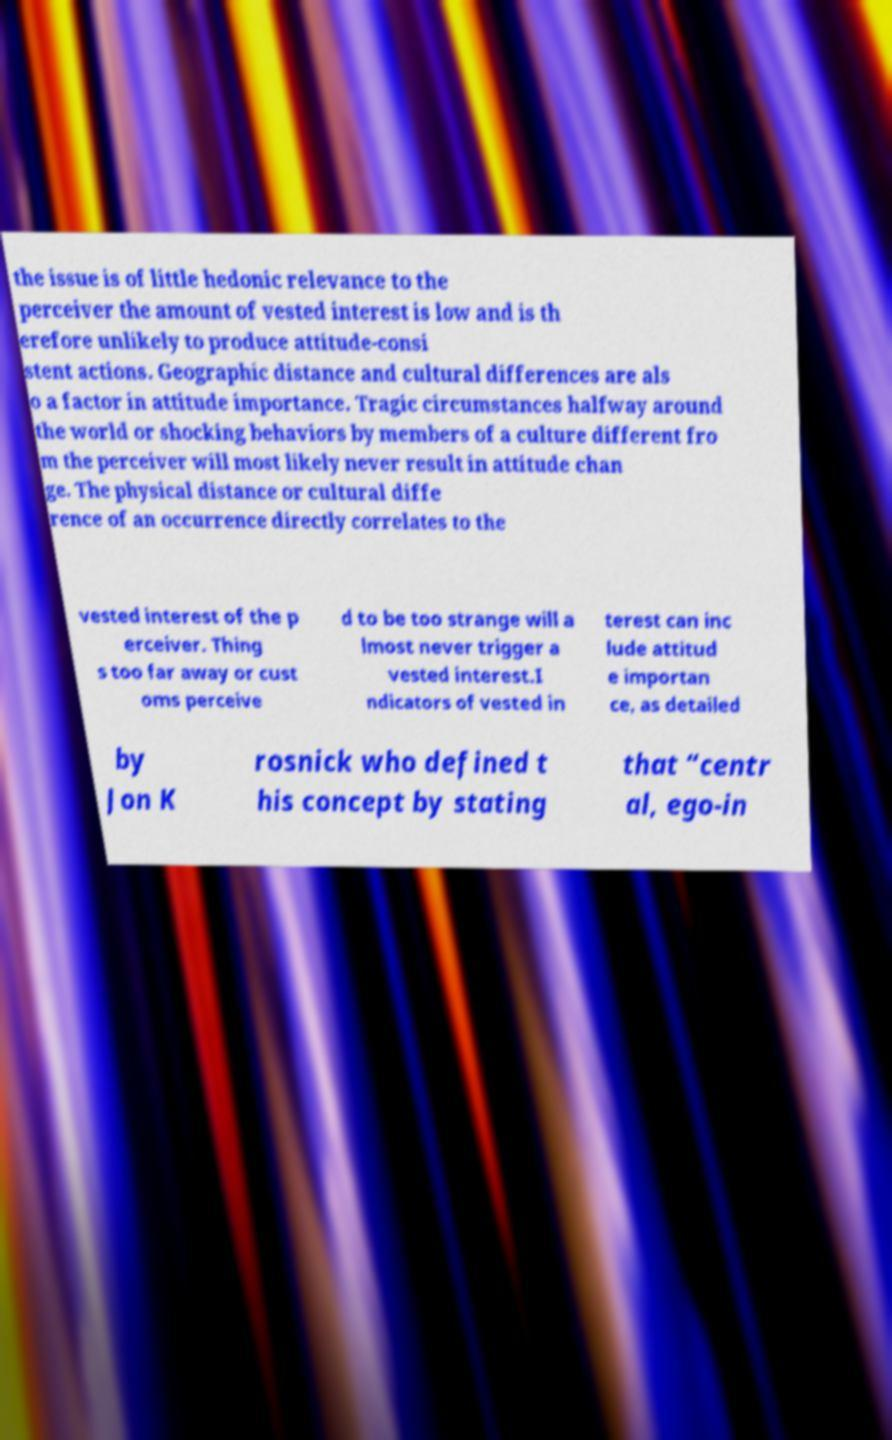What messages or text are displayed in this image? I need them in a readable, typed format. the issue is of little hedonic relevance to the perceiver the amount of vested interest is low and is th erefore unlikely to produce attitude-consi stent actions. Geographic distance and cultural differences are als o a factor in attitude importance. Tragic circumstances halfway around the world or shocking behaviors by members of a culture different fro m the perceiver will most likely never result in attitude chan ge. The physical distance or cultural diffe rence of an occurrence directly correlates to the vested interest of the p erceiver. Thing s too far away or cust oms perceive d to be too strange will a lmost never trigger a vested interest.I ndicators of vested in terest can inc lude attitud e importan ce, as detailed by Jon K rosnick who defined t his concept by stating that “centr al, ego-in 